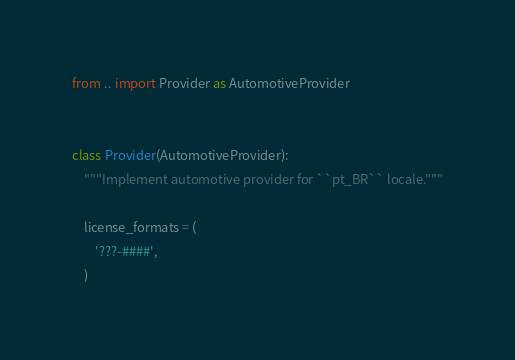<code> <loc_0><loc_0><loc_500><loc_500><_Python_>from .. import Provider as AutomotiveProvider


class Provider(AutomotiveProvider):
    """Implement automotive provider for ``pt_BR`` locale."""

    license_formats = (
        '???-####',
    )
</code> 